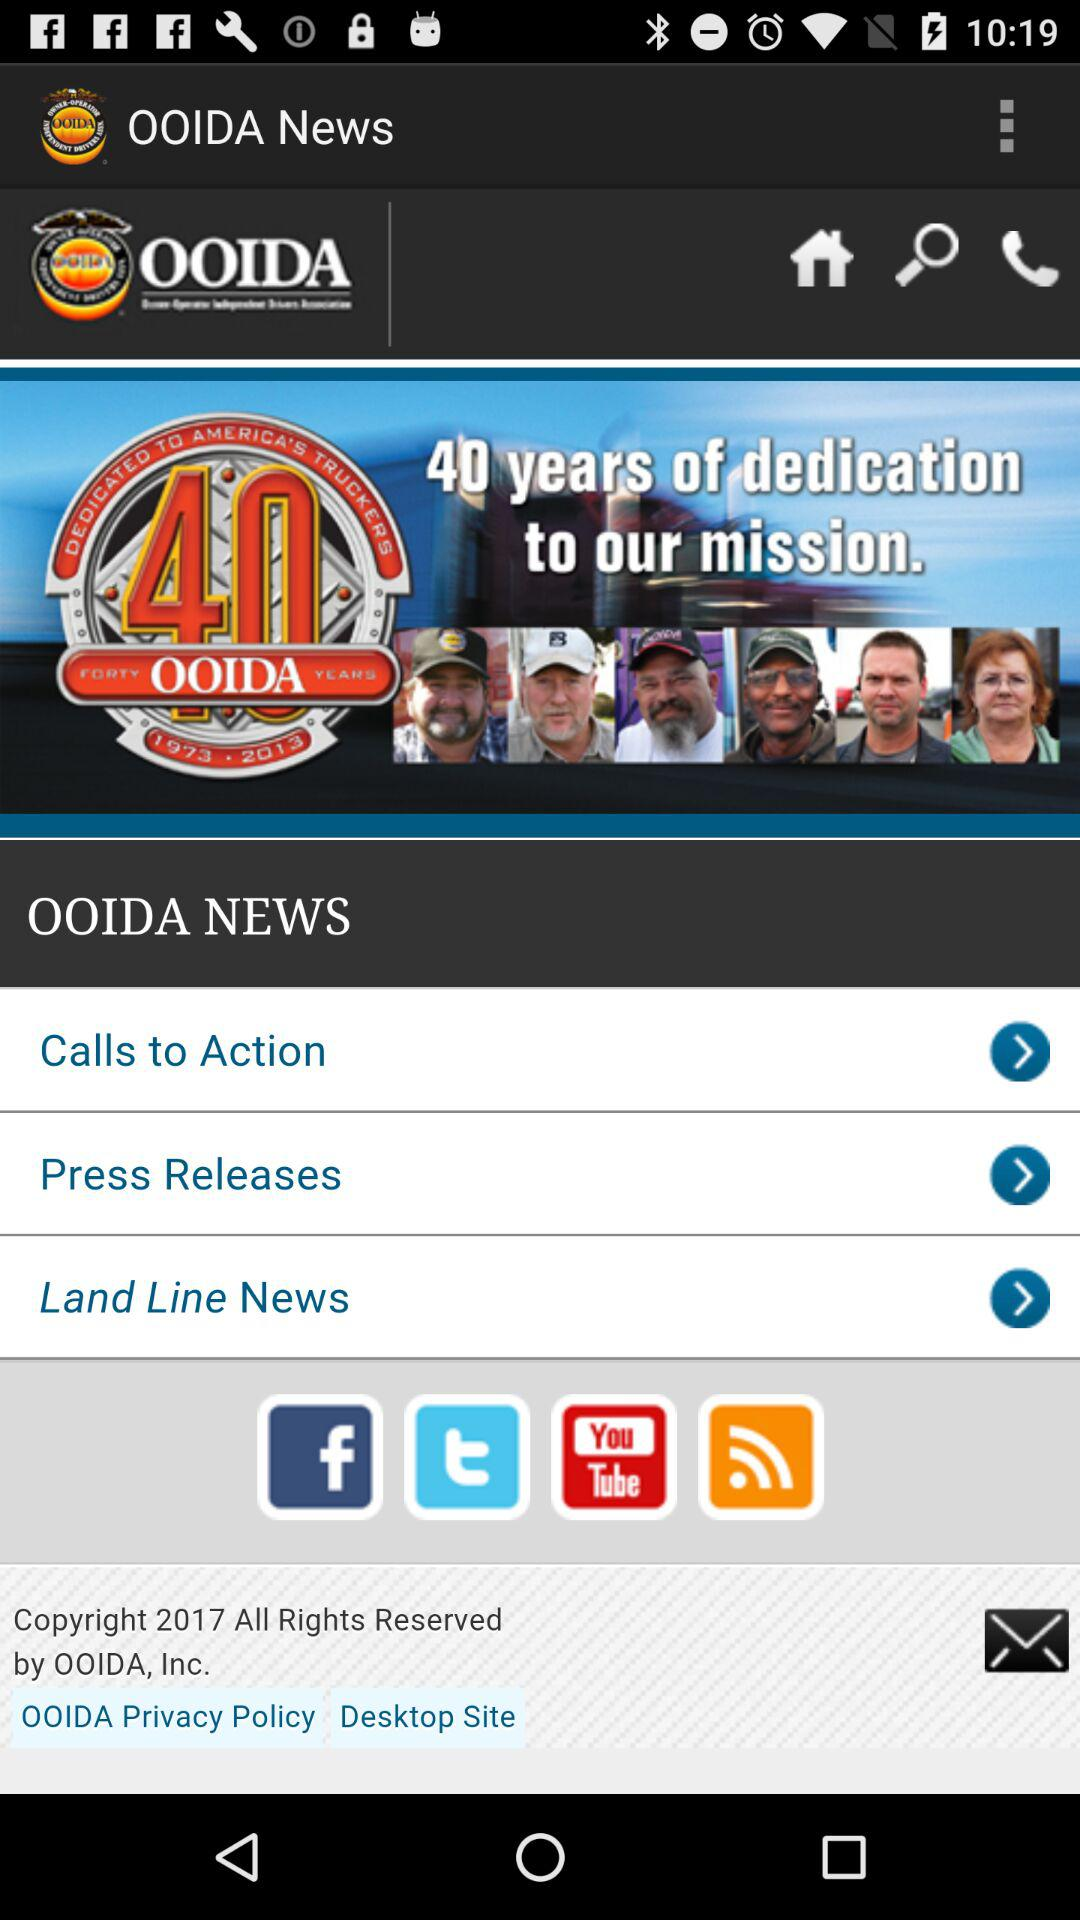What is the name of the application? The name of the application is "OOIDA News". 